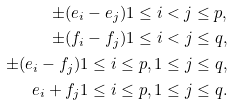Convert formula to latex. <formula><loc_0><loc_0><loc_500><loc_500>\pm ( e _ { i } - e _ { j } ) 1 \leq i < j \leq p , \\ \pm ( f _ { i } - f _ { j } ) 1 \leq i < j \leq q , \\ \pm ( e _ { i } - f _ { j } ) 1 \leq i \leq p , 1 \leq j \leq q , \\ e _ { i } + f _ { j } 1 \leq i \leq p , 1 \leq j \leq q .</formula> 